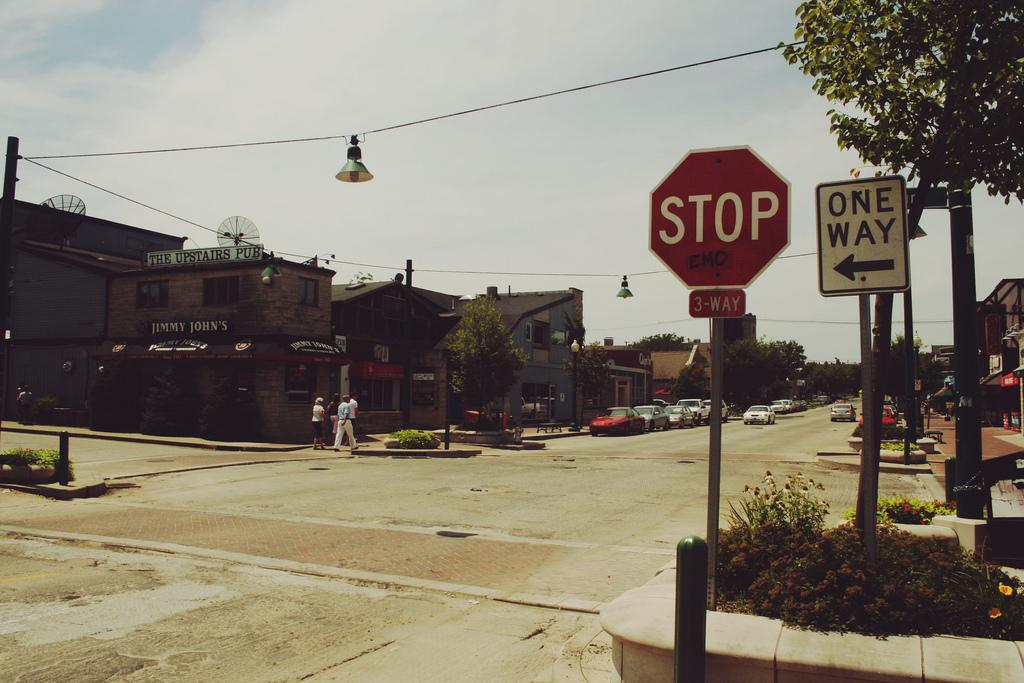Question: how many road signs are there?
Choices:
A. Two.
B. Five.
C. Three.
D. Seven.
Answer with the letter. Answer: A Question: what is the most prominent road sign?
Choices:
A. Yield sign.
B. Stop sign.
C. No parking sign.
D. School area sign.
Answer with the letter. Answer: B Question: how many people are standing at the road corner?
Choices:
A. Seven.
B. Fourty.
C. Three.
D. Four.
Answer with the letter. Answer: D Question: what is the color of first parked car?
Choices:
A. Red.
B. Blue.
C. Pink.
D. Orange.
Answer with the letter. Answer: A Question: what is the second road sign?
Choices:
A. Two way.
B. Stop sign.
C. Yield sign.
D. One way.
Answer with the letter. Answer: D Question: what is hanging overhead?
Choices:
A. Rooftop.
B. Awnings.
C. Banners.
D. Street light.
Answer with the letter. Answer: D Question: how does the road look?
Choices:
A. Rough.
B. Bumpy.
C. Worn down.
D. Paved and light brown.
Answer with the letter. Answer: D Question: how does the sky look?
Choices:
A. Sunny.
B. Clear.
C. Dark.
D. Cloudy.
Answer with the letter. Answer: D Question: how do the crosswalks appear?
Choices:
A. White lines guiding the way.
B. A maze of lines on black road ways.
C. Paved in faded red brick.
D. Walking signals beeping colors.
Answer with the letter. Answer: C Question: how does the picture look?
Choices:
A. De-saturated in color.
B. Blurry.
C. Too dark.
D. Pixelated.
Answer with the letter. Answer: A Question: where is the one way sign pointing?
Choices:
A. Right.
B. Left.
C. Forward.
D. Backwards.
Answer with the letter. Answer: B Question: who is on the left?
Choices:
A. People walking.
B. Children playing.
C. Animals walking.
D. Couples.
Answer with the letter. Answer: A Question: where are people standing?
Choices:
A. In the street.
B. On the sidewalk.
C. On the corner.
D. Next to a building.
Answer with the letter. Answer: C Question: what is behind the sign?
Choices:
A. A bush.
B. A plant.
C. A tree.
D. A log.
Answer with the letter. Answer: C Question: what are on some of the buildings?
Choices:
A. Windows.
B. Signs.
C. Lights.
D. Satellite antennas.
Answer with the letter. Answer: D Question: who wears a light blue shirt?
Choices:
A. The man.
B. The lady.
C. A boy on a bike.
D. One of the people walking in the distance.
Answer with the letter. Answer: D Question: what does the placard on the stop sign say?
Choices:
A. 3-Way.
B. No left turns on red.
C. Right turns on red.
D. Stop.
Answer with the letter. Answer: A 